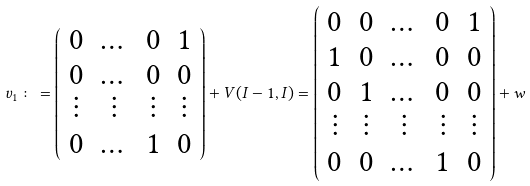<formula> <loc_0><loc_0><loc_500><loc_500>v _ { 1 } \colon = \left ( \begin{array} { c c c c } 0 & \dots & 0 & 1 \\ 0 & \dots & 0 & 0 \\ \vdots & \vdots & \vdots & \vdots \\ 0 & \dots & 1 & 0 \\ \end{array} \right ) + V ( I - 1 , I ) = \left ( \begin{array} { c c c c c } 0 & 0 & \dots & 0 & 1 \\ 1 & 0 & \dots & 0 & 0 \\ 0 & 1 & \dots & 0 & 0 \\ \vdots & \vdots & \vdots & \vdots & \vdots \\ 0 & 0 & \dots & 1 & 0 \\ \end{array} \right ) + w</formula> 